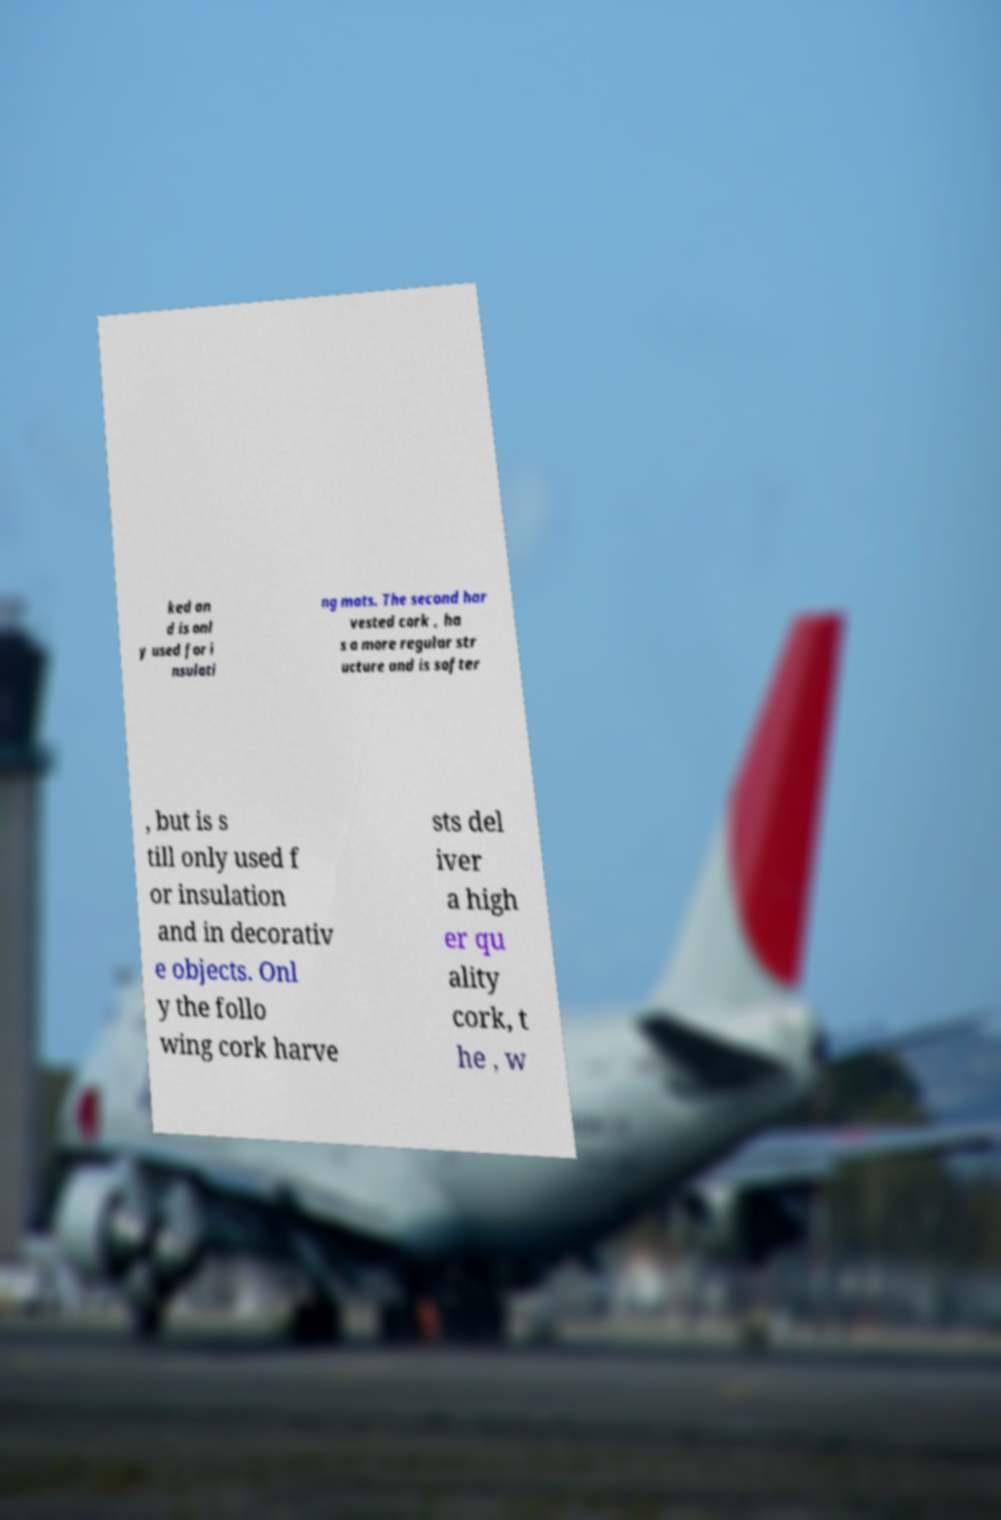There's text embedded in this image that I need extracted. Can you transcribe it verbatim? ked an d is onl y used for i nsulati ng mats. The second har vested cork , ha s a more regular str ucture and is softer , but is s till only used f or insulation and in decorativ e objects. Onl y the follo wing cork harve sts del iver a high er qu ality cork, t he , w 